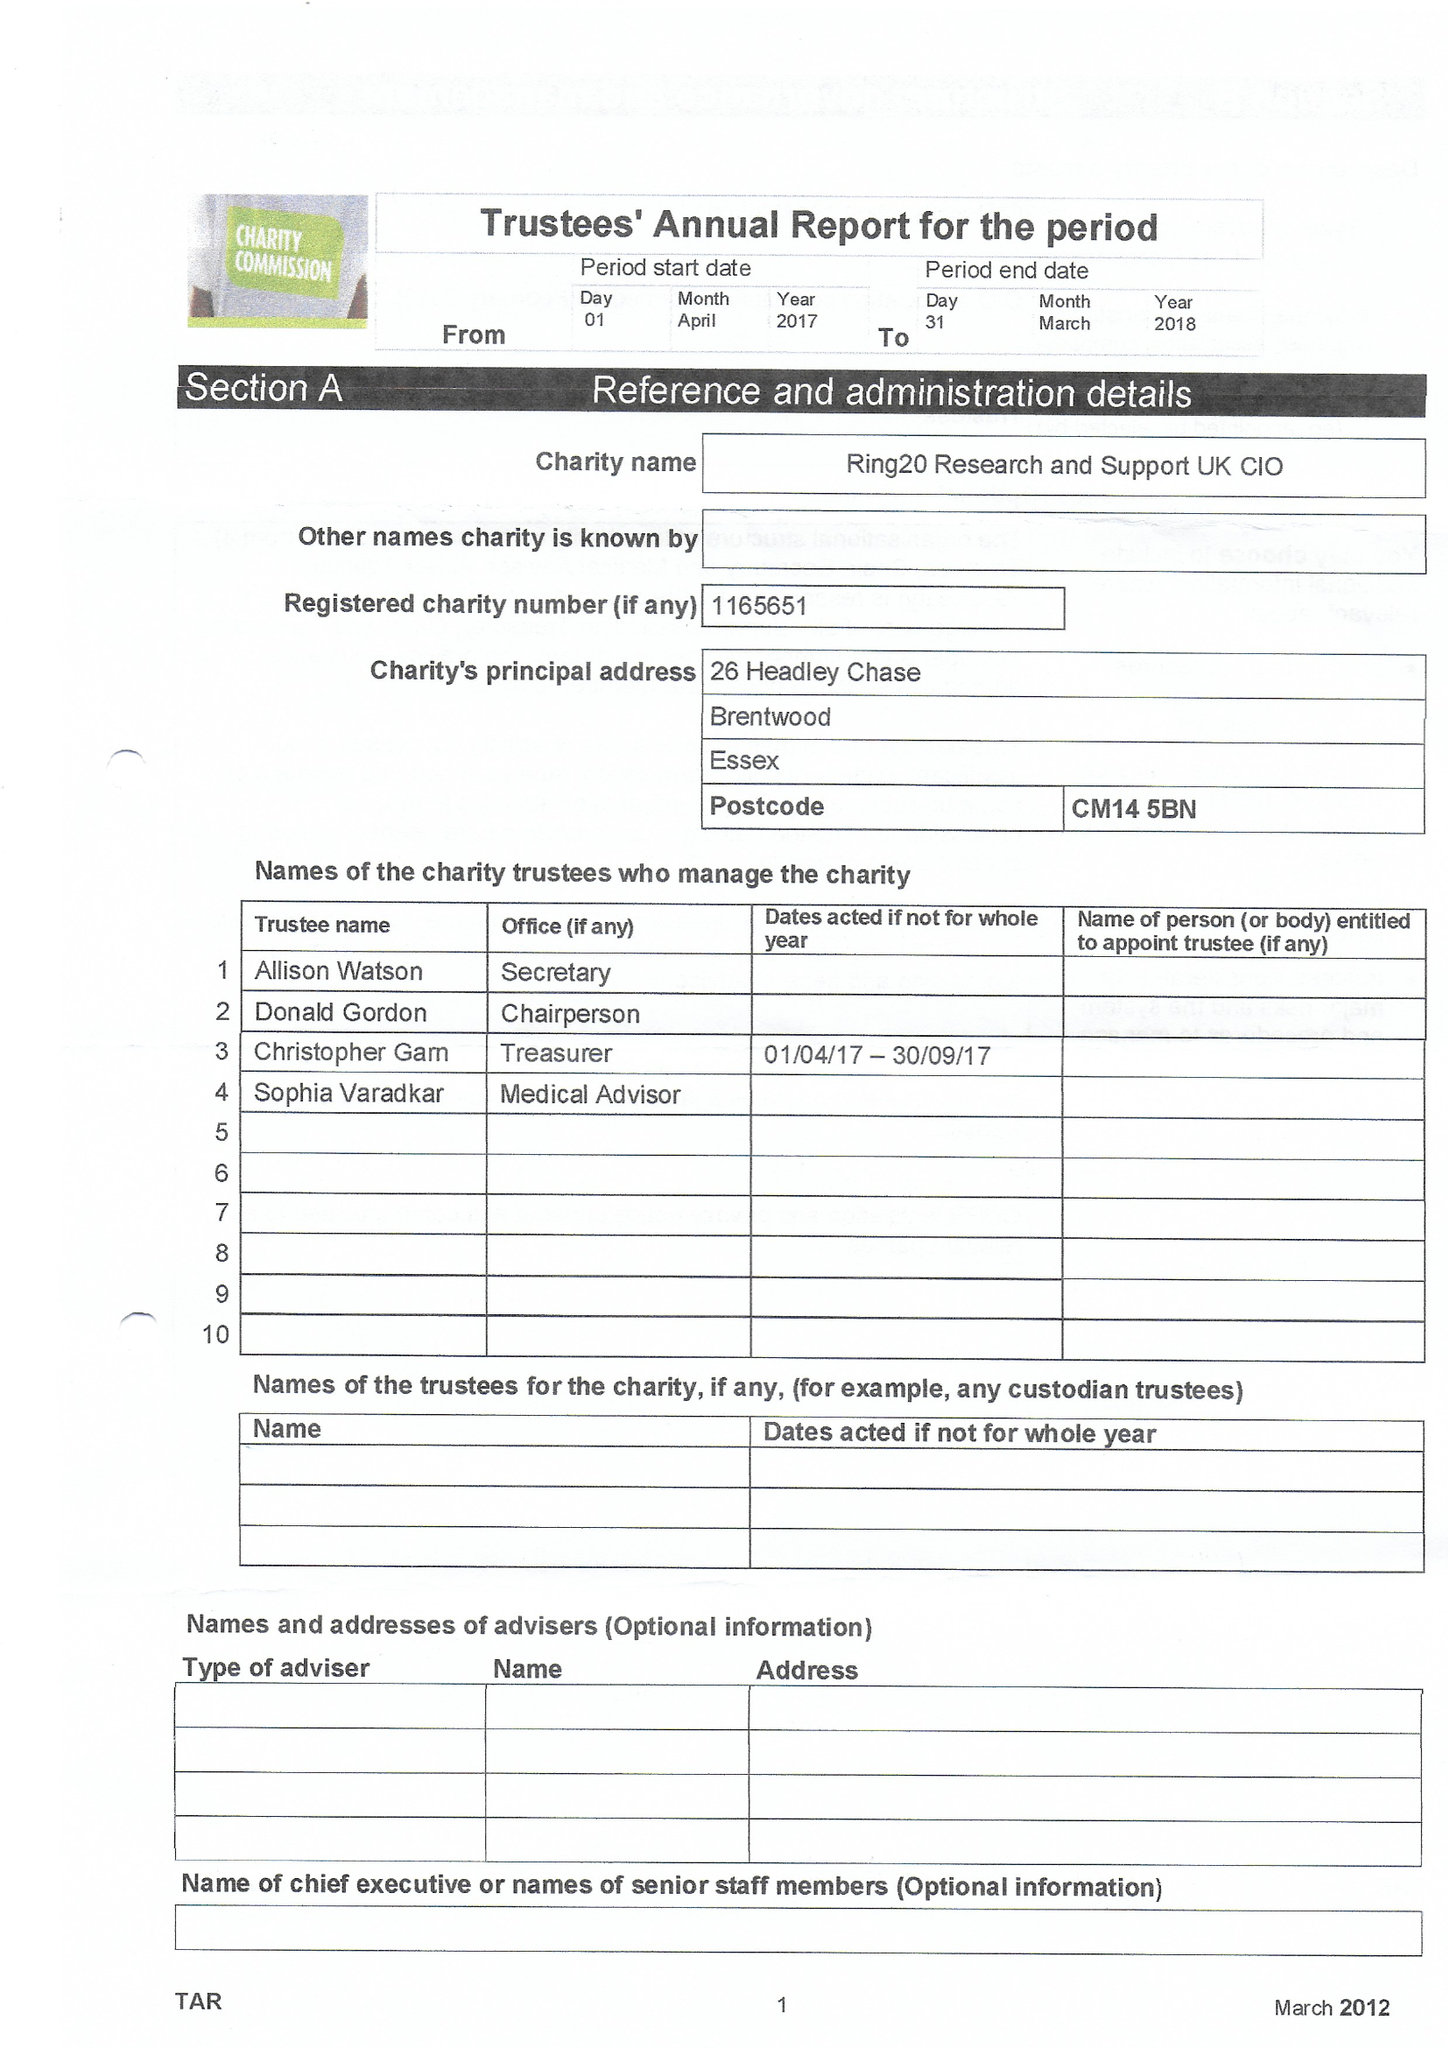What is the value for the charity_name?
Answer the question using a single word or phrase. Ring20 Research and Support Uk CIO 